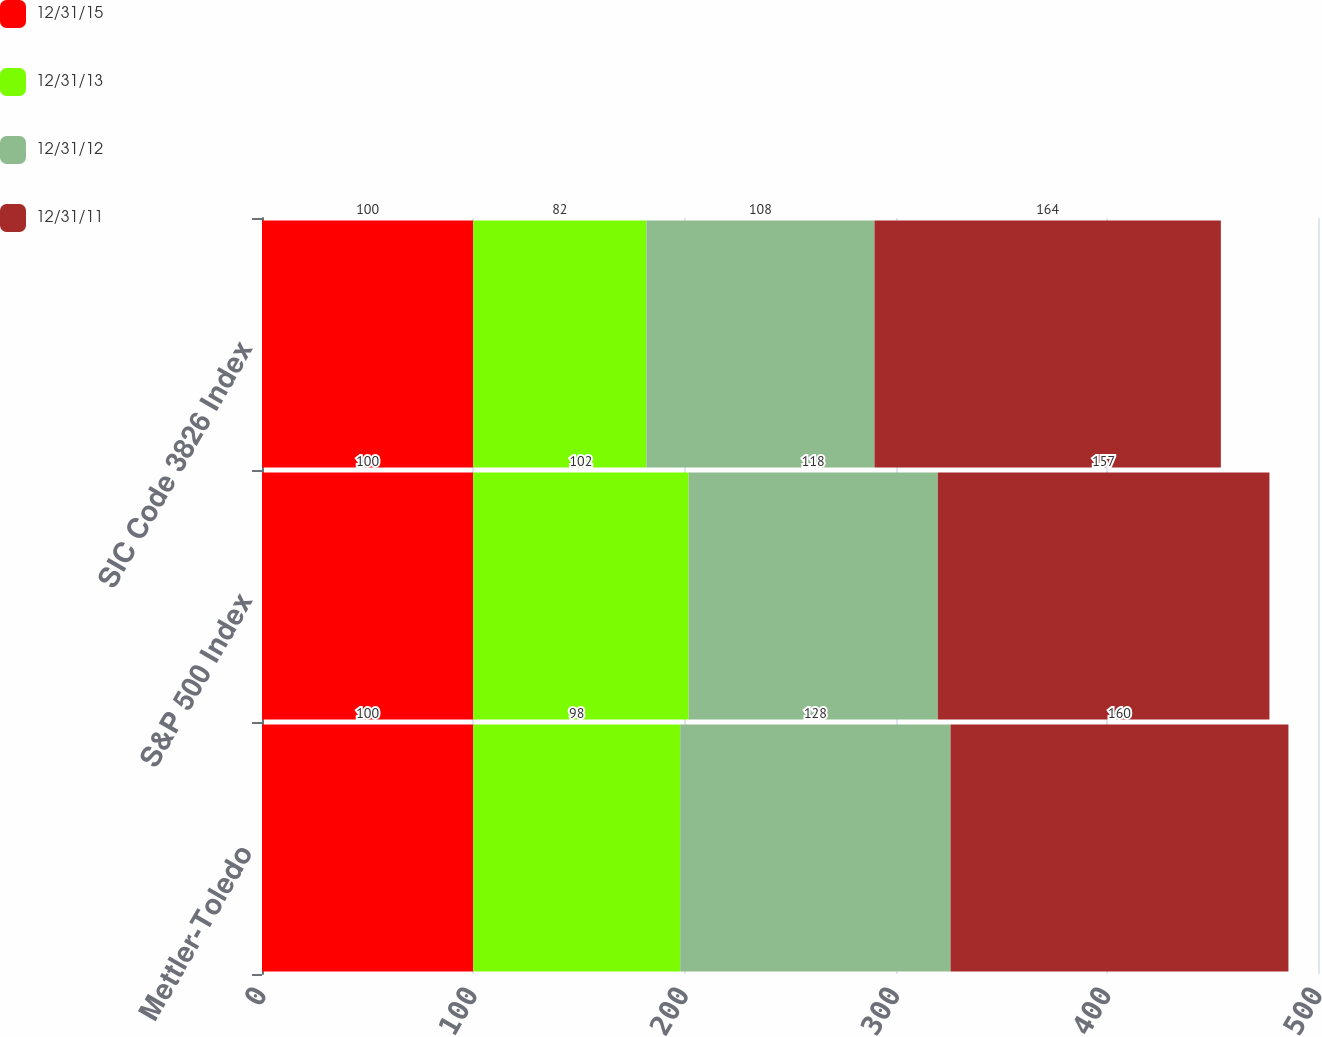<chart> <loc_0><loc_0><loc_500><loc_500><stacked_bar_chart><ecel><fcel>Mettler-Toledo<fcel>S&P 500 Index<fcel>SIC Code 3826 Index<nl><fcel>12/31/15<fcel>100<fcel>100<fcel>100<nl><fcel>12/31/13<fcel>98<fcel>102<fcel>82<nl><fcel>12/31/12<fcel>128<fcel>118<fcel>108<nl><fcel>12/31/11<fcel>160<fcel>157<fcel>164<nl></chart> 